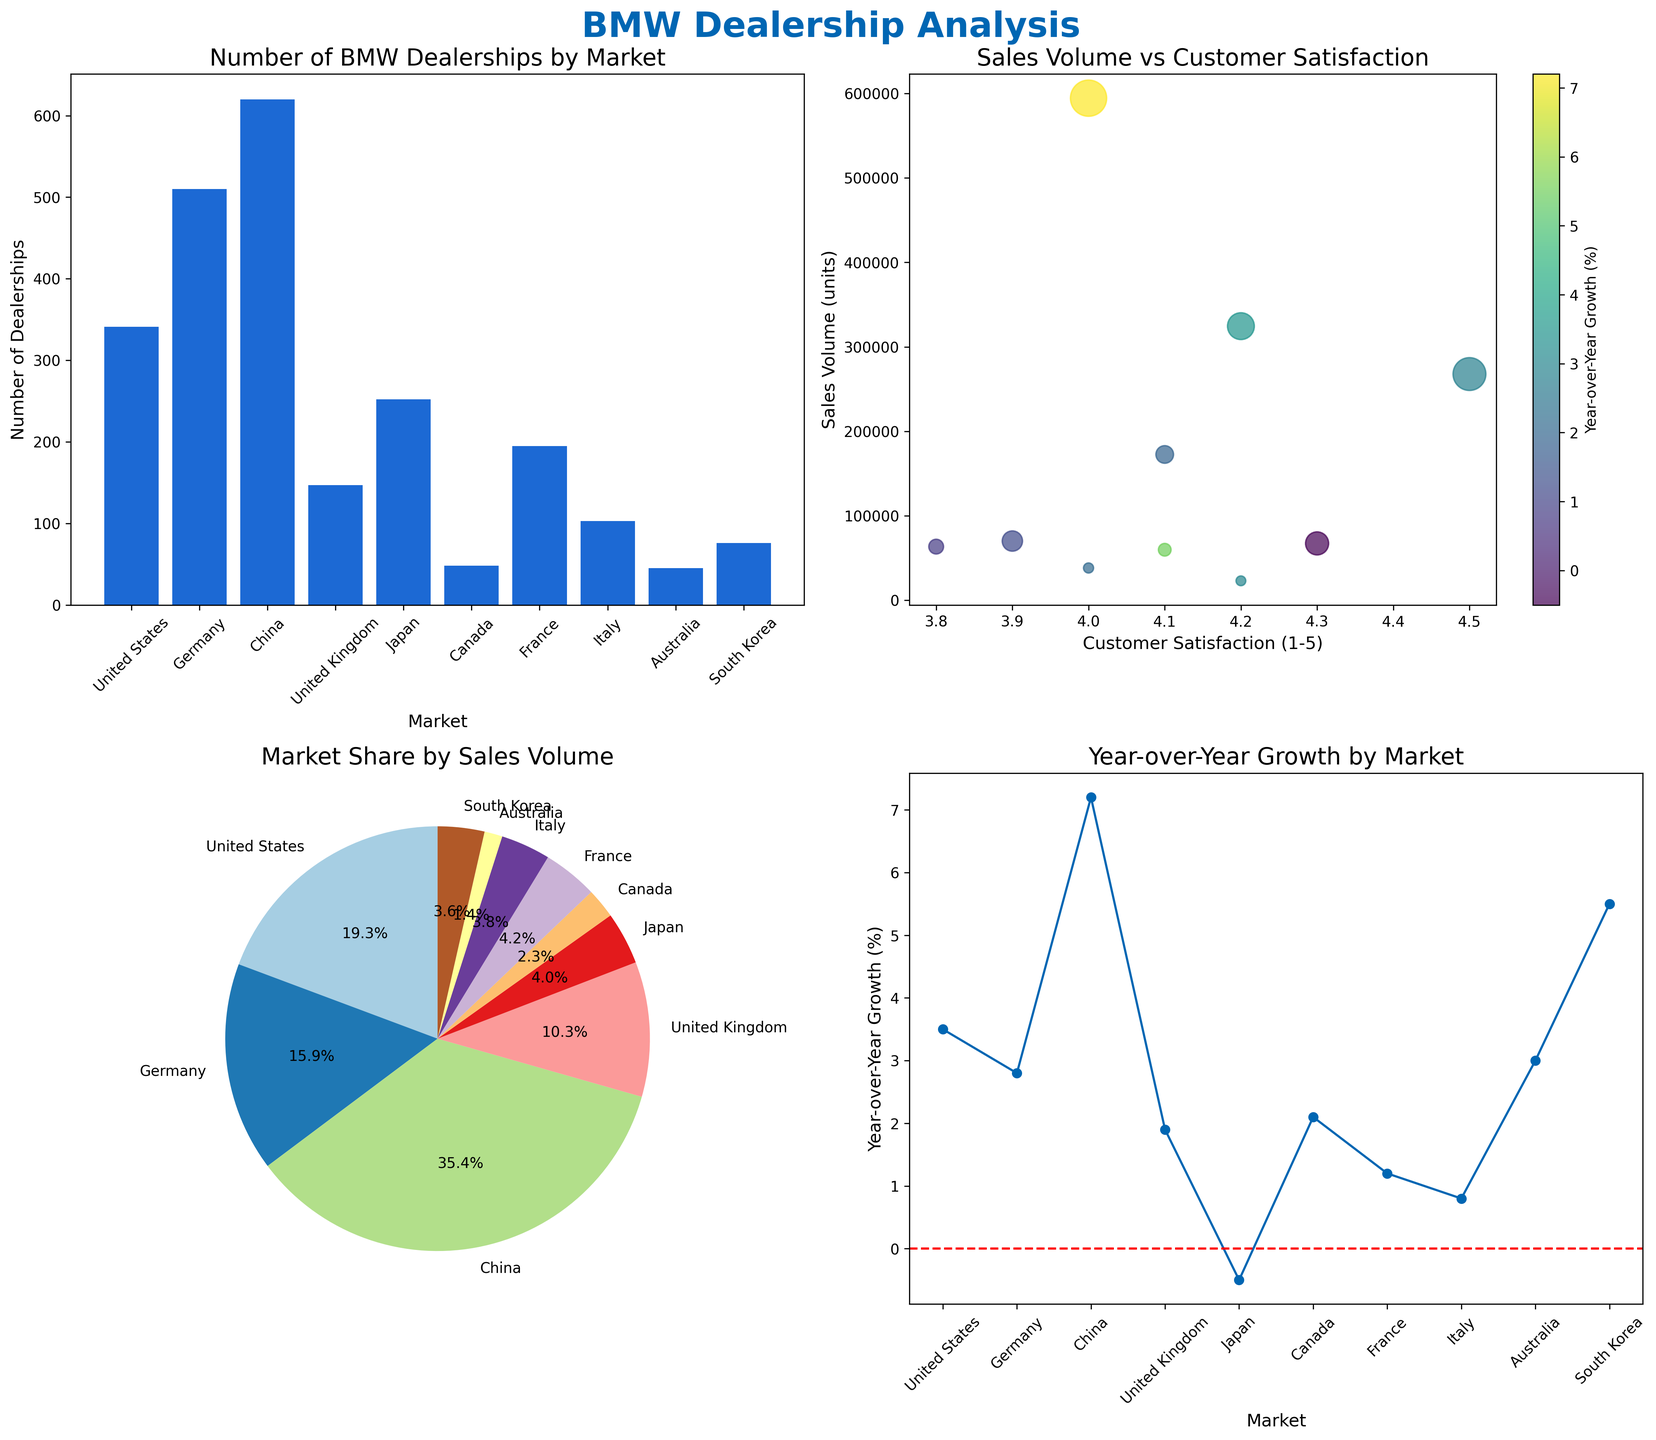How many markets have more than 200 BMW dealerships? Look at the bar plot titled 'Number of BMW Dealerships by Market' and count the number of markets where the bar height exceeds 200. The markets are Germany, China, Japan, and the United States, which totals four markets.
Answer: 4 What is the sales volume for the BMW market with the highest customer satisfaction rating? In the scatter plot 'Sales Volume vs Customer Satisfaction,' find the data point with the highest customer satisfaction rating, which is Germany (4.5). The corresponding sales volume for Germany is 267,800 units.
Answer: 267,800 Which market has the smallest year-over-year growth rate? In the line plot 'Year-over-Year Growth by Market,' look for the market with the lowest point on the y-axis. Japan has the smallest year-over-year growth rate at -0.5%.
Answer: Japan What is the approximate percentage market share of France based on sales volume? Refer to the pie chart 'Market Share by Sales Volume.' Find the segment labeled as France and look at the percentage label, which is around 5.9%.
Answer: 5.9% How many BMW dealerships are there in South Korea and Australia combined? In the bar plot 'Number of BMW Dealerships by Market,' identify the number of dealerships in South Korea (76) and Australia (45). Sum these numbers: 76 + 45 = 121.
Answer: 121 Which market has both high customer satisfaction (above 4) and low sales volume (below 100,000 units)? In the scatter plot 'Sales Volume vs Customer Satisfaction,' find the market that meets both conditions. Japan has a customer satisfaction of 4.3 and a sales volume of 67,300 units.
Answer: Japan Between Canada and Italy, which market has higher year-over-year growth? Look at the line plot 'Year-over-Year Growth by Market' and compare the y-values for Canada and Italy. Canada's growth is 2.1%, while Italy's is 0.8%. Canada has higher growth.
Answer: Canada What is the difference in the number of dealerships between the market with the most and the least dealerships? In the bar plot 'Number of BMW Dealerships by Market,' find China (620 dealerships) has the most, and Australia (45 dealerships) has the least. The difference is 620 - 45 = 575.
Answer: 575 